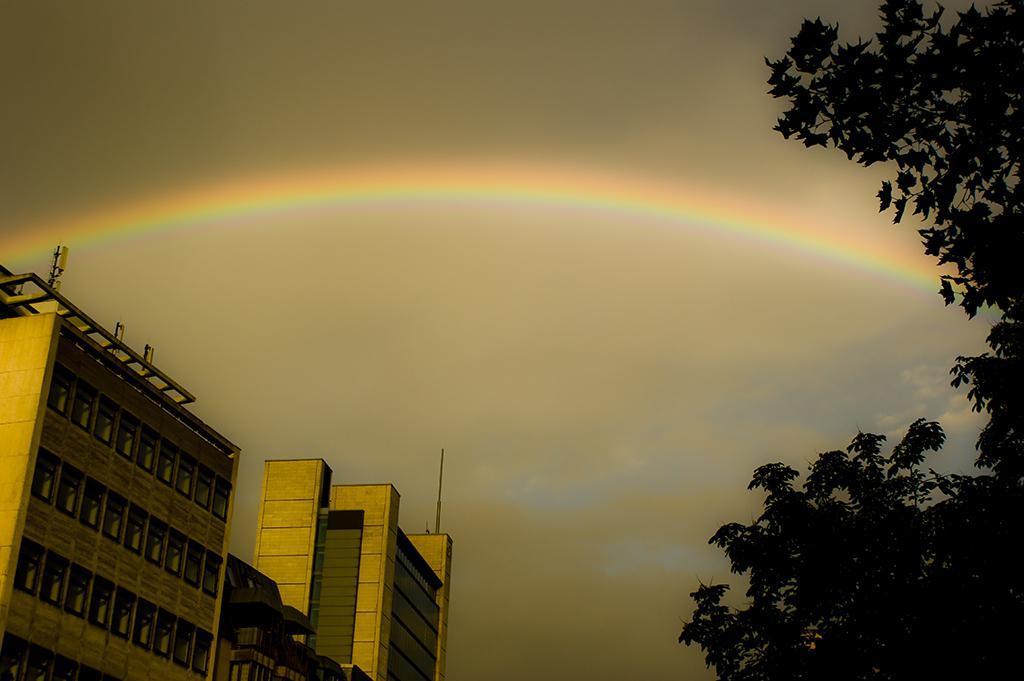Describe this image in one or two sentences. There are trees at the right. There are buildings at the left and there is a rainbow in the sky. 